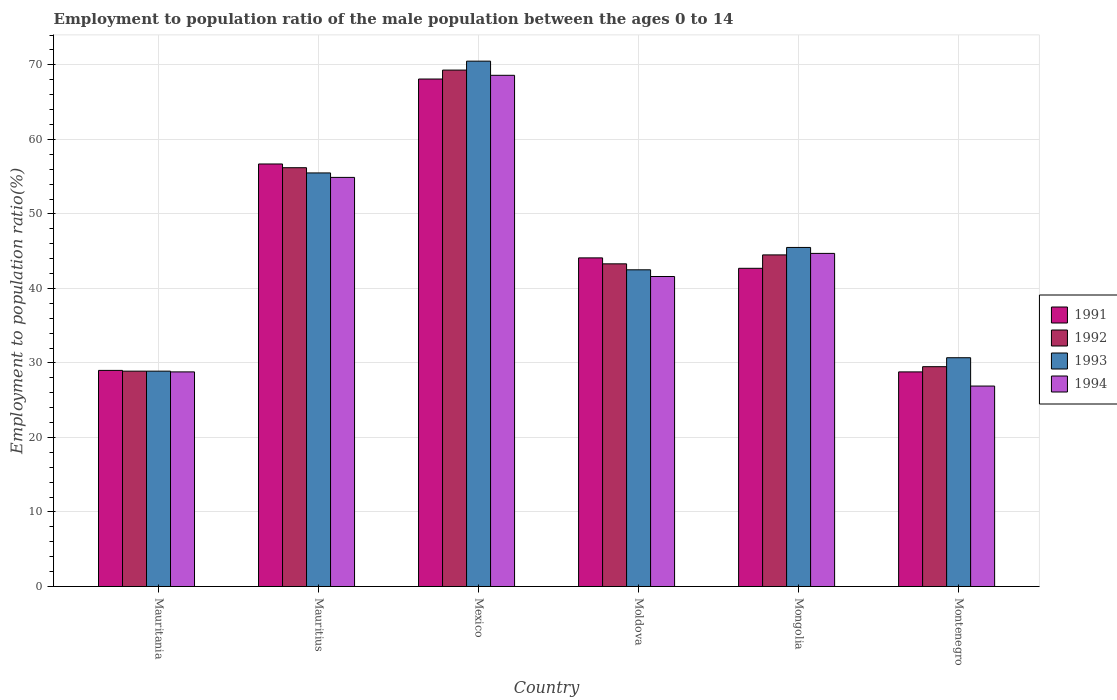Are the number of bars per tick equal to the number of legend labels?
Your answer should be very brief. Yes. Are the number of bars on each tick of the X-axis equal?
Give a very brief answer. Yes. What is the label of the 4th group of bars from the left?
Your response must be concise. Moldova. What is the employment to population ratio in 1994 in Mexico?
Make the answer very short. 68.6. Across all countries, what is the maximum employment to population ratio in 1991?
Provide a succinct answer. 68.1. Across all countries, what is the minimum employment to population ratio in 1994?
Your response must be concise. 26.9. In which country was the employment to population ratio in 1992 maximum?
Offer a very short reply. Mexico. In which country was the employment to population ratio in 1992 minimum?
Offer a terse response. Mauritania. What is the total employment to population ratio in 1992 in the graph?
Keep it short and to the point. 271.7. What is the difference between the employment to population ratio in 1993 in Moldova and the employment to population ratio in 1992 in Mauritius?
Your answer should be very brief. -13.7. What is the average employment to population ratio in 1993 per country?
Make the answer very short. 45.6. What is the difference between the employment to population ratio of/in 1993 and employment to population ratio of/in 1992 in Moldova?
Make the answer very short. -0.8. In how many countries, is the employment to population ratio in 1994 greater than 14 %?
Your answer should be compact. 6. What is the ratio of the employment to population ratio in 1993 in Mauritania to that in Moldova?
Offer a terse response. 0.68. Is the difference between the employment to population ratio in 1993 in Moldova and Montenegro greater than the difference between the employment to population ratio in 1992 in Moldova and Montenegro?
Provide a short and direct response. No. What is the difference between the highest and the second highest employment to population ratio in 1993?
Offer a terse response. -25. What is the difference between the highest and the lowest employment to population ratio in 1992?
Give a very brief answer. 40.4. In how many countries, is the employment to population ratio in 1991 greater than the average employment to population ratio in 1991 taken over all countries?
Your answer should be compact. 2. What does the 3rd bar from the right in Montenegro represents?
Make the answer very short. 1992. Is it the case that in every country, the sum of the employment to population ratio in 1991 and employment to population ratio in 1993 is greater than the employment to population ratio in 1994?
Provide a succinct answer. Yes. How many bars are there?
Your answer should be very brief. 24. Are all the bars in the graph horizontal?
Make the answer very short. No. What is the difference between two consecutive major ticks on the Y-axis?
Provide a short and direct response. 10. Are the values on the major ticks of Y-axis written in scientific E-notation?
Provide a short and direct response. No. Does the graph contain grids?
Make the answer very short. Yes. How many legend labels are there?
Your answer should be compact. 4. What is the title of the graph?
Provide a short and direct response. Employment to population ratio of the male population between the ages 0 to 14. What is the label or title of the X-axis?
Offer a terse response. Country. What is the label or title of the Y-axis?
Provide a short and direct response. Employment to population ratio(%). What is the Employment to population ratio(%) in 1992 in Mauritania?
Your response must be concise. 28.9. What is the Employment to population ratio(%) of 1993 in Mauritania?
Provide a succinct answer. 28.9. What is the Employment to population ratio(%) of 1994 in Mauritania?
Ensure brevity in your answer.  28.8. What is the Employment to population ratio(%) of 1991 in Mauritius?
Provide a succinct answer. 56.7. What is the Employment to population ratio(%) in 1992 in Mauritius?
Your answer should be compact. 56.2. What is the Employment to population ratio(%) in 1993 in Mauritius?
Your answer should be compact. 55.5. What is the Employment to population ratio(%) in 1994 in Mauritius?
Make the answer very short. 54.9. What is the Employment to population ratio(%) in 1991 in Mexico?
Your answer should be compact. 68.1. What is the Employment to population ratio(%) of 1992 in Mexico?
Give a very brief answer. 69.3. What is the Employment to population ratio(%) in 1993 in Mexico?
Your answer should be compact. 70.5. What is the Employment to population ratio(%) in 1994 in Mexico?
Your answer should be compact. 68.6. What is the Employment to population ratio(%) of 1991 in Moldova?
Make the answer very short. 44.1. What is the Employment to population ratio(%) of 1992 in Moldova?
Give a very brief answer. 43.3. What is the Employment to population ratio(%) of 1993 in Moldova?
Make the answer very short. 42.5. What is the Employment to population ratio(%) of 1994 in Moldova?
Provide a short and direct response. 41.6. What is the Employment to population ratio(%) in 1991 in Mongolia?
Offer a terse response. 42.7. What is the Employment to population ratio(%) in 1992 in Mongolia?
Ensure brevity in your answer.  44.5. What is the Employment to population ratio(%) in 1993 in Mongolia?
Give a very brief answer. 45.5. What is the Employment to population ratio(%) of 1994 in Mongolia?
Ensure brevity in your answer.  44.7. What is the Employment to population ratio(%) in 1991 in Montenegro?
Provide a succinct answer. 28.8. What is the Employment to population ratio(%) of 1992 in Montenegro?
Ensure brevity in your answer.  29.5. What is the Employment to population ratio(%) of 1993 in Montenegro?
Ensure brevity in your answer.  30.7. What is the Employment to population ratio(%) of 1994 in Montenegro?
Provide a succinct answer. 26.9. Across all countries, what is the maximum Employment to population ratio(%) in 1991?
Give a very brief answer. 68.1. Across all countries, what is the maximum Employment to population ratio(%) in 1992?
Make the answer very short. 69.3. Across all countries, what is the maximum Employment to population ratio(%) of 1993?
Keep it short and to the point. 70.5. Across all countries, what is the maximum Employment to population ratio(%) in 1994?
Offer a very short reply. 68.6. Across all countries, what is the minimum Employment to population ratio(%) in 1991?
Provide a succinct answer. 28.8. Across all countries, what is the minimum Employment to population ratio(%) in 1992?
Your answer should be compact. 28.9. Across all countries, what is the minimum Employment to population ratio(%) in 1993?
Give a very brief answer. 28.9. Across all countries, what is the minimum Employment to population ratio(%) of 1994?
Offer a terse response. 26.9. What is the total Employment to population ratio(%) of 1991 in the graph?
Make the answer very short. 269.4. What is the total Employment to population ratio(%) in 1992 in the graph?
Offer a very short reply. 271.7. What is the total Employment to population ratio(%) of 1993 in the graph?
Your answer should be compact. 273.6. What is the total Employment to population ratio(%) of 1994 in the graph?
Your answer should be very brief. 265.5. What is the difference between the Employment to population ratio(%) of 1991 in Mauritania and that in Mauritius?
Ensure brevity in your answer.  -27.7. What is the difference between the Employment to population ratio(%) in 1992 in Mauritania and that in Mauritius?
Give a very brief answer. -27.3. What is the difference between the Employment to population ratio(%) in 1993 in Mauritania and that in Mauritius?
Make the answer very short. -26.6. What is the difference between the Employment to population ratio(%) in 1994 in Mauritania and that in Mauritius?
Give a very brief answer. -26.1. What is the difference between the Employment to population ratio(%) in 1991 in Mauritania and that in Mexico?
Make the answer very short. -39.1. What is the difference between the Employment to population ratio(%) of 1992 in Mauritania and that in Mexico?
Your response must be concise. -40.4. What is the difference between the Employment to population ratio(%) in 1993 in Mauritania and that in Mexico?
Ensure brevity in your answer.  -41.6. What is the difference between the Employment to population ratio(%) of 1994 in Mauritania and that in Mexico?
Offer a terse response. -39.8. What is the difference between the Employment to population ratio(%) of 1991 in Mauritania and that in Moldova?
Offer a terse response. -15.1. What is the difference between the Employment to population ratio(%) in 1992 in Mauritania and that in Moldova?
Your answer should be compact. -14.4. What is the difference between the Employment to population ratio(%) of 1991 in Mauritania and that in Mongolia?
Ensure brevity in your answer.  -13.7. What is the difference between the Employment to population ratio(%) of 1992 in Mauritania and that in Mongolia?
Offer a very short reply. -15.6. What is the difference between the Employment to population ratio(%) in 1993 in Mauritania and that in Mongolia?
Offer a terse response. -16.6. What is the difference between the Employment to population ratio(%) in 1994 in Mauritania and that in Mongolia?
Your answer should be very brief. -15.9. What is the difference between the Employment to population ratio(%) in 1991 in Mauritania and that in Montenegro?
Keep it short and to the point. 0.2. What is the difference between the Employment to population ratio(%) in 1992 in Mauritania and that in Montenegro?
Offer a terse response. -0.6. What is the difference between the Employment to population ratio(%) in 1994 in Mauritania and that in Montenegro?
Ensure brevity in your answer.  1.9. What is the difference between the Employment to population ratio(%) in 1993 in Mauritius and that in Mexico?
Your response must be concise. -15. What is the difference between the Employment to population ratio(%) in 1994 in Mauritius and that in Mexico?
Give a very brief answer. -13.7. What is the difference between the Employment to population ratio(%) of 1991 in Mauritius and that in Moldova?
Make the answer very short. 12.6. What is the difference between the Employment to population ratio(%) of 1993 in Mauritius and that in Moldova?
Keep it short and to the point. 13. What is the difference between the Employment to population ratio(%) in 1991 in Mauritius and that in Mongolia?
Provide a succinct answer. 14. What is the difference between the Employment to population ratio(%) of 1991 in Mauritius and that in Montenegro?
Give a very brief answer. 27.9. What is the difference between the Employment to population ratio(%) in 1992 in Mauritius and that in Montenegro?
Your answer should be very brief. 26.7. What is the difference between the Employment to population ratio(%) of 1993 in Mauritius and that in Montenegro?
Ensure brevity in your answer.  24.8. What is the difference between the Employment to population ratio(%) of 1994 in Mexico and that in Moldova?
Make the answer very short. 27. What is the difference between the Employment to population ratio(%) of 1991 in Mexico and that in Mongolia?
Provide a succinct answer. 25.4. What is the difference between the Employment to population ratio(%) of 1992 in Mexico and that in Mongolia?
Ensure brevity in your answer.  24.8. What is the difference between the Employment to population ratio(%) in 1994 in Mexico and that in Mongolia?
Keep it short and to the point. 23.9. What is the difference between the Employment to population ratio(%) in 1991 in Mexico and that in Montenegro?
Offer a very short reply. 39.3. What is the difference between the Employment to population ratio(%) of 1992 in Mexico and that in Montenegro?
Your answer should be compact. 39.8. What is the difference between the Employment to population ratio(%) in 1993 in Mexico and that in Montenegro?
Offer a very short reply. 39.8. What is the difference between the Employment to population ratio(%) in 1994 in Mexico and that in Montenegro?
Offer a terse response. 41.7. What is the difference between the Employment to population ratio(%) of 1992 in Moldova and that in Mongolia?
Offer a terse response. -1.2. What is the difference between the Employment to population ratio(%) in 1991 in Moldova and that in Montenegro?
Keep it short and to the point. 15.3. What is the difference between the Employment to population ratio(%) of 1991 in Mongolia and that in Montenegro?
Provide a short and direct response. 13.9. What is the difference between the Employment to population ratio(%) of 1992 in Mongolia and that in Montenegro?
Your answer should be very brief. 15. What is the difference between the Employment to population ratio(%) of 1994 in Mongolia and that in Montenegro?
Provide a short and direct response. 17.8. What is the difference between the Employment to population ratio(%) of 1991 in Mauritania and the Employment to population ratio(%) of 1992 in Mauritius?
Offer a very short reply. -27.2. What is the difference between the Employment to population ratio(%) in 1991 in Mauritania and the Employment to population ratio(%) in 1993 in Mauritius?
Your response must be concise. -26.5. What is the difference between the Employment to population ratio(%) of 1991 in Mauritania and the Employment to population ratio(%) of 1994 in Mauritius?
Make the answer very short. -25.9. What is the difference between the Employment to population ratio(%) in 1992 in Mauritania and the Employment to population ratio(%) in 1993 in Mauritius?
Give a very brief answer. -26.6. What is the difference between the Employment to population ratio(%) in 1992 in Mauritania and the Employment to population ratio(%) in 1994 in Mauritius?
Make the answer very short. -26. What is the difference between the Employment to population ratio(%) in 1993 in Mauritania and the Employment to population ratio(%) in 1994 in Mauritius?
Keep it short and to the point. -26. What is the difference between the Employment to population ratio(%) in 1991 in Mauritania and the Employment to population ratio(%) in 1992 in Mexico?
Keep it short and to the point. -40.3. What is the difference between the Employment to population ratio(%) in 1991 in Mauritania and the Employment to population ratio(%) in 1993 in Mexico?
Give a very brief answer. -41.5. What is the difference between the Employment to population ratio(%) in 1991 in Mauritania and the Employment to population ratio(%) in 1994 in Mexico?
Make the answer very short. -39.6. What is the difference between the Employment to population ratio(%) in 1992 in Mauritania and the Employment to population ratio(%) in 1993 in Mexico?
Keep it short and to the point. -41.6. What is the difference between the Employment to population ratio(%) of 1992 in Mauritania and the Employment to population ratio(%) of 1994 in Mexico?
Your answer should be very brief. -39.7. What is the difference between the Employment to population ratio(%) of 1993 in Mauritania and the Employment to population ratio(%) of 1994 in Mexico?
Make the answer very short. -39.7. What is the difference between the Employment to population ratio(%) in 1991 in Mauritania and the Employment to population ratio(%) in 1992 in Moldova?
Your answer should be very brief. -14.3. What is the difference between the Employment to population ratio(%) of 1991 in Mauritania and the Employment to population ratio(%) of 1993 in Moldova?
Offer a terse response. -13.5. What is the difference between the Employment to population ratio(%) in 1991 in Mauritania and the Employment to population ratio(%) in 1994 in Moldova?
Provide a succinct answer. -12.6. What is the difference between the Employment to population ratio(%) in 1992 in Mauritania and the Employment to population ratio(%) in 1993 in Moldova?
Keep it short and to the point. -13.6. What is the difference between the Employment to population ratio(%) of 1993 in Mauritania and the Employment to population ratio(%) of 1994 in Moldova?
Keep it short and to the point. -12.7. What is the difference between the Employment to population ratio(%) of 1991 in Mauritania and the Employment to population ratio(%) of 1992 in Mongolia?
Keep it short and to the point. -15.5. What is the difference between the Employment to population ratio(%) of 1991 in Mauritania and the Employment to population ratio(%) of 1993 in Mongolia?
Keep it short and to the point. -16.5. What is the difference between the Employment to population ratio(%) of 1991 in Mauritania and the Employment to population ratio(%) of 1994 in Mongolia?
Your answer should be compact. -15.7. What is the difference between the Employment to population ratio(%) of 1992 in Mauritania and the Employment to population ratio(%) of 1993 in Mongolia?
Offer a very short reply. -16.6. What is the difference between the Employment to population ratio(%) of 1992 in Mauritania and the Employment to population ratio(%) of 1994 in Mongolia?
Your response must be concise. -15.8. What is the difference between the Employment to population ratio(%) in 1993 in Mauritania and the Employment to population ratio(%) in 1994 in Mongolia?
Provide a succinct answer. -15.8. What is the difference between the Employment to population ratio(%) in 1992 in Mauritania and the Employment to population ratio(%) in 1993 in Montenegro?
Give a very brief answer. -1.8. What is the difference between the Employment to population ratio(%) in 1992 in Mauritius and the Employment to population ratio(%) in 1993 in Mexico?
Offer a very short reply. -14.3. What is the difference between the Employment to population ratio(%) of 1992 in Mauritius and the Employment to population ratio(%) of 1994 in Mexico?
Ensure brevity in your answer.  -12.4. What is the difference between the Employment to population ratio(%) in 1991 in Mauritius and the Employment to population ratio(%) in 1994 in Moldova?
Provide a succinct answer. 15.1. What is the difference between the Employment to population ratio(%) of 1992 in Mauritius and the Employment to population ratio(%) of 1993 in Moldova?
Offer a terse response. 13.7. What is the difference between the Employment to population ratio(%) of 1992 in Mauritius and the Employment to population ratio(%) of 1994 in Moldova?
Keep it short and to the point. 14.6. What is the difference between the Employment to population ratio(%) of 1991 in Mauritius and the Employment to population ratio(%) of 1994 in Mongolia?
Provide a short and direct response. 12. What is the difference between the Employment to population ratio(%) of 1993 in Mauritius and the Employment to population ratio(%) of 1994 in Mongolia?
Make the answer very short. 10.8. What is the difference between the Employment to population ratio(%) in 1991 in Mauritius and the Employment to population ratio(%) in 1992 in Montenegro?
Offer a terse response. 27.2. What is the difference between the Employment to population ratio(%) in 1991 in Mauritius and the Employment to population ratio(%) in 1993 in Montenegro?
Keep it short and to the point. 26. What is the difference between the Employment to population ratio(%) in 1991 in Mauritius and the Employment to population ratio(%) in 1994 in Montenegro?
Give a very brief answer. 29.8. What is the difference between the Employment to population ratio(%) in 1992 in Mauritius and the Employment to population ratio(%) in 1993 in Montenegro?
Provide a succinct answer. 25.5. What is the difference between the Employment to population ratio(%) in 1992 in Mauritius and the Employment to population ratio(%) in 1994 in Montenegro?
Offer a terse response. 29.3. What is the difference between the Employment to population ratio(%) of 1993 in Mauritius and the Employment to population ratio(%) of 1994 in Montenegro?
Your answer should be very brief. 28.6. What is the difference between the Employment to population ratio(%) in 1991 in Mexico and the Employment to population ratio(%) in 1992 in Moldova?
Offer a very short reply. 24.8. What is the difference between the Employment to population ratio(%) in 1991 in Mexico and the Employment to population ratio(%) in 1993 in Moldova?
Your answer should be very brief. 25.6. What is the difference between the Employment to population ratio(%) of 1992 in Mexico and the Employment to population ratio(%) of 1993 in Moldova?
Give a very brief answer. 26.8. What is the difference between the Employment to population ratio(%) in 1992 in Mexico and the Employment to population ratio(%) in 1994 in Moldova?
Your response must be concise. 27.7. What is the difference between the Employment to population ratio(%) in 1993 in Mexico and the Employment to population ratio(%) in 1994 in Moldova?
Your response must be concise. 28.9. What is the difference between the Employment to population ratio(%) of 1991 in Mexico and the Employment to population ratio(%) of 1992 in Mongolia?
Offer a terse response. 23.6. What is the difference between the Employment to population ratio(%) of 1991 in Mexico and the Employment to population ratio(%) of 1993 in Mongolia?
Your answer should be very brief. 22.6. What is the difference between the Employment to population ratio(%) of 1991 in Mexico and the Employment to population ratio(%) of 1994 in Mongolia?
Make the answer very short. 23.4. What is the difference between the Employment to population ratio(%) of 1992 in Mexico and the Employment to population ratio(%) of 1993 in Mongolia?
Offer a terse response. 23.8. What is the difference between the Employment to population ratio(%) in 1992 in Mexico and the Employment to population ratio(%) in 1994 in Mongolia?
Provide a short and direct response. 24.6. What is the difference between the Employment to population ratio(%) in 1993 in Mexico and the Employment to population ratio(%) in 1994 in Mongolia?
Give a very brief answer. 25.8. What is the difference between the Employment to population ratio(%) in 1991 in Mexico and the Employment to population ratio(%) in 1992 in Montenegro?
Offer a terse response. 38.6. What is the difference between the Employment to population ratio(%) in 1991 in Mexico and the Employment to population ratio(%) in 1993 in Montenegro?
Your answer should be very brief. 37.4. What is the difference between the Employment to population ratio(%) of 1991 in Mexico and the Employment to population ratio(%) of 1994 in Montenegro?
Your response must be concise. 41.2. What is the difference between the Employment to population ratio(%) in 1992 in Mexico and the Employment to population ratio(%) in 1993 in Montenegro?
Your answer should be compact. 38.6. What is the difference between the Employment to population ratio(%) of 1992 in Mexico and the Employment to population ratio(%) of 1994 in Montenegro?
Give a very brief answer. 42.4. What is the difference between the Employment to population ratio(%) of 1993 in Mexico and the Employment to population ratio(%) of 1994 in Montenegro?
Give a very brief answer. 43.6. What is the difference between the Employment to population ratio(%) in 1991 in Moldova and the Employment to population ratio(%) in 1992 in Mongolia?
Your answer should be compact. -0.4. What is the difference between the Employment to population ratio(%) in 1993 in Moldova and the Employment to population ratio(%) in 1994 in Mongolia?
Provide a short and direct response. -2.2. What is the difference between the Employment to population ratio(%) in 1991 in Moldova and the Employment to population ratio(%) in 1992 in Montenegro?
Provide a short and direct response. 14.6. What is the difference between the Employment to population ratio(%) in 1991 in Moldova and the Employment to population ratio(%) in 1993 in Montenegro?
Make the answer very short. 13.4. What is the difference between the Employment to population ratio(%) of 1991 in Moldova and the Employment to population ratio(%) of 1994 in Montenegro?
Ensure brevity in your answer.  17.2. What is the difference between the Employment to population ratio(%) of 1991 in Mongolia and the Employment to population ratio(%) of 1992 in Montenegro?
Provide a succinct answer. 13.2. What is the difference between the Employment to population ratio(%) in 1991 in Mongolia and the Employment to population ratio(%) in 1994 in Montenegro?
Ensure brevity in your answer.  15.8. What is the difference between the Employment to population ratio(%) in 1992 in Mongolia and the Employment to population ratio(%) in 1993 in Montenegro?
Your response must be concise. 13.8. What is the average Employment to population ratio(%) in 1991 per country?
Give a very brief answer. 44.9. What is the average Employment to population ratio(%) of 1992 per country?
Your answer should be compact. 45.28. What is the average Employment to population ratio(%) in 1993 per country?
Make the answer very short. 45.6. What is the average Employment to population ratio(%) of 1994 per country?
Your answer should be compact. 44.25. What is the difference between the Employment to population ratio(%) of 1991 and Employment to population ratio(%) of 1992 in Mauritania?
Your response must be concise. 0.1. What is the difference between the Employment to population ratio(%) in 1991 and Employment to population ratio(%) in 1993 in Mauritania?
Your response must be concise. 0.1. What is the difference between the Employment to population ratio(%) in 1992 and Employment to population ratio(%) in 1993 in Mauritania?
Your answer should be very brief. 0. What is the difference between the Employment to population ratio(%) in 1993 and Employment to population ratio(%) in 1994 in Mauritania?
Your response must be concise. 0.1. What is the difference between the Employment to population ratio(%) of 1991 and Employment to population ratio(%) of 1992 in Mauritius?
Your answer should be compact. 0.5. What is the difference between the Employment to population ratio(%) in 1992 and Employment to population ratio(%) in 1993 in Mauritius?
Your response must be concise. 0.7. What is the difference between the Employment to population ratio(%) of 1993 and Employment to population ratio(%) of 1994 in Mauritius?
Your answer should be compact. 0.6. What is the difference between the Employment to population ratio(%) in 1991 and Employment to population ratio(%) in 1992 in Mexico?
Your answer should be very brief. -1.2. What is the difference between the Employment to population ratio(%) in 1991 and Employment to population ratio(%) in 1993 in Mexico?
Ensure brevity in your answer.  -2.4. What is the difference between the Employment to population ratio(%) in 1992 and Employment to population ratio(%) in 1993 in Mexico?
Your answer should be compact. -1.2. What is the difference between the Employment to population ratio(%) of 1991 and Employment to population ratio(%) of 1992 in Moldova?
Keep it short and to the point. 0.8. What is the difference between the Employment to population ratio(%) in 1991 and Employment to population ratio(%) in 1993 in Moldova?
Give a very brief answer. 1.6. What is the difference between the Employment to population ratio(%) of 1993 and Employment to population ratio(%) of 1994 in Moldova?
Give a very brief answer. 0.9. What is the difference between the Employment to population ratio(%) of 1991 and Employment to population ratio(%) of 1992 in Mongolia?
Your answer should be compact. -1.8. What is the difference between the Employment to population ratio(%) in 1992 and Employment to population ratio(%) in 1993 in Mongolia?
Keep it short and to the point. -1. What is the difference between the Employment to population ratio(%) in 1992 and Employment to population ratio(%) in 1994 in Mongolia?
Make the answer very short. -0.2. What is the difference between the Employment to population ratio(%) of 1991 and Employment to population ratio(%) of 1992 in Montenegro?
Offer a very short reply. -0.7. What is the difference between the Employment to population ratio(%) of 1991 and Employment to population ratio(%) of 1993 in Montenegro?
Provide a short and direct response. -1.9. What is the difference between the Employment to population ratio(%) of 1992 and Employment to population ratio(%) of 1993 in Montenegro?
Give a very brief answer. -1.2. What is the difference between the Employment to population ratio(%) in 1992 and Employment to population ratio(%) in 1994 in Montenegro?
Offer a very short reply. 2.6. What is the ratio of the Employment to population ratio(%) in 1991 in Mauritania to that in Mauritius?
Your answer should be compact. 0.51. What is the ratio of the Employment to population ratio(%) of 1992 in Mauritania to that in Mauritius?
Provide a short and direct response. 0.51. What is the ratio of the Employment to population ratio(%) in 1993 in Mauritania to that in Mauritius?
Offer a very short reply. 0.52. What is the ratio of the Employment to population ratio(%) of 1994 in Mauritania to that in Mauritius?
Ensure brevity in your answer.  0.52. What is the ratio of the Employment to population ratio(%) in 1991 in Mauritania to that in Mexico?
Ensure brevity in your answer.  0.43. What is the ratio of the Employment to population ratio(%) in 1992 in Mauritania to that in Mexico?
Your answer should be compact. 0.42. What is the ratio of the Employment to population ratio(%) in 1993 in Mauritania to that in Mexico?
Provide a short and direct response. 0.41. What is the ratio of the Employment to population ratio(%) of 1994 in Mauritania to that in Mexico?
Offer a very short reply. 0.42. What is the ratio of the Employment to population ratio(%) in 1991 in Mauritania to that in Moldova?
Provide a short and direct response. 0.66. What is the ratio of the Employment to population ratio(%) in 1992 in Mauritania to that in Moldova?
Give a very brief answer. 0.67. What is the ratio of the Employment to population ratio(%) in 1993 in Mauritania to that in Moldova?
Provide a succinct answer. 0.68. What is the ratio of the Employment to population ratio(%) in 1994 in Mauritania to that in Moldova?
Your answer should be compact. 0.69. What is the ratio of the Employment to population ratio(%) in 1991 in Mauritania to that in Mongolia?
Your answer should be compact. 0.68. What is the ratio of the Employment to population ratio(%) of 1992 in Mauritania to that in Mongolia?
Offer a very short reply. 0.65. What is the ratio of the Employment to population ratio(%) of 1993 in Mauritania to that in Mongolia?
Ensure brevity in your answer.  0.64. What is the ratio of the Employment to population ratio(%) in 1994 in Mauritania to that in Mongolia?
Provide a short and direct response. 0.64. What is the ratio of the Employment to population ratio(%) in 1992 in Mauritania to that in Montenegro?
Offer a very short reply. 0.98. What is the ratio of the Employment to population ratio(%) in 1993 in Mauritania to that in Montenegro?
Offer a terse response. 0.94. What is the ratio of the Employment to population ratio(%) in 1994 in Mauritania to that in Montenegro?
Provide a short and direct response. 1.07. What is the ratio of the Employment to population ratio(%) in 1991 in Mauritius to that in Mexico?
Offer a terse response. 0.83. What is the ratio of the Employment to population ratio(%) of 1992 in Mauritius to that in Mexico?
Offer a very short reply. 0.81. What is the ratio of the Employment to population ratio(%) of 1993 in Mauritius to that in Mexico?
Offer a terse response. 0.79. What is the ratio of the Employment to population ratio(%) in 1994 in Mauritius to that in Mexico?
Your answer should be very brief. 0.8. What is the ratio of the Employment to population ratio(%) in 1992 in Mauritius to that in Moldova?
Make the answer very short. 1.3. What is the ratio of the Employment to population ratio(%) in 1993 in Mauritius to that in Moldova?
Keep it short and to the point. 1.31. What is the ratio of the Employment to population ratio(%) of 1994 in Mauritius to that in Moldova?
Your answer should be compact. 1.32. What is the ratio of the Employment to population ratio(%) of 1991 in Mauritius to that in Mongolia?
Ensure brevity in your answer.  1.33. What is the ratio of the Employment to population ratio(%) in 1992 in Mauritius to that in Mongolia?
Offer a very short reply. 1.26. What is the ratio of the Employment to population ratio(%) in 1993 in Mauritius to that in Mongolia?
Make the answer very short. 1.22. What is the ratio of the Employment to population ratio(%) in 1994 in Mauritius to that in Mongolia?
Give a very brief answer. 1.23. What is the ratio of the Employment to population ratio(%) of 1991 in Mauritius to that in Montenegro?
Give a very brief answer. 1.97. What is the ratio of the Employment to population ratio(%) of 1992 in Mauritius to that in Montenegro?
Give a very brief answer. 1.91. What is the ratio of the Employment to population ratio(%) in 1993 in Mauritius to that in Montenegro?
Offer a terse response. 1.81. What is the ratio of the Employment to population ratio(%) of 1994 in Mauritius to that in Montenegro?
Offer a terse response. 2.04. What is the ratio of the Employment to population ratio(%) in 1991 in Mexico to that in Moldova?
Provide a succinct answer. 1.54. What is the ratio of the Employment to population ratio(%) in 1992 in Mexico to that in Moldova?
Your answer should be compact. 1.6. What is the ratio of the Employment to population ratio(%) in 1993 in Mexico to that in Moldova?
Your answer should be compact. 1.66. What is the ratio of the Employment to population ratio(%) of 1994 in Mexico to that in Moldova?
Offer a terse response. 1.65. What is the ratio of the Employment to population ratio(%) in 1991 in Mexico to that in Mongolia?
Keep it short and to the point. 1.59. What is the ratio of the Employment to population ratio(%) in 1992 in Mexico to that in Mongolia?
Offer a terse response. 1.56. What is the ratio of the Employment to population ratio(%) in 1993 in Mexico to that in Mongolia?
Offer a terse response. 1.55. What is the ratio of the Employment to population ratio(%) in 1994 in Mexico to that in Mongolia?
Provide a succinct answer. 1.53. What is the ratio of the Employment to population ratio(%) of 1991 in Mexico to that in Montenegro?
Your response must be concise. 2.36. What is the ratio of the Employment to population ratio(%) in 1992 in Mexico to that in Montenegro?
Offer a terse response. 2.35. What is the ratio of the Employment to population ratio(%) of 1993 in Mexico to that in Montenegro?
Your answer should be very brief. 2.3. What is the ratio of the Employment to population ratio(%) of 1994 in Mexico to that in Montenegro?
Provide a succinct answer. 2.55. What is the ratio of the Employment to population ratio(%) of 1991 in Moldova to that in Mongolia?
Your answer should be very brief. 1.03. What is the ratio of the Employment to population ratio(%) in 1992 in Moldova to that in Mongolia?
Provide a short and direct response. 0.97. What is the ratio of the Employment to population ratio(%) of 1993 in Moldova to that in Mongolia?
Provide a succinct answer. 0.93. What is the ratio of the Employment to population ratio(%) in 1994 in Moldova to that in Mongolia?
Keep it short and to the point. 0.93. What is the ratio of the Employment to population ratio(%) of 1991 in Moldova to that in Montenegro?
Provide a short and direct response. 1.53. What is the ratio of the Employment to population ratio(%) in 1992 in Moldova to that in Montenegro?
Ensure brevity in your answer.  1.47. What is the ratio of the Employment to population ratio(%) of 1993 in Moldova to that in Montenegro?
Your response must be concise. 1.38. What is the ratio of the Employment to population ratio(%) in 1994 in Moldova to that in Montenegro?
Ensure brevity in your answer.  1.55. What is the ratio of the Employment to population ratio(%) of 1991 in Mongolia to that in Montenegro?
Your response must be concise. 1.48. What is the ratio of the Employment to population ratio(%) in 1992 in Mongolia to that in Montenegro?
Your answer should be very brief. 1.51. What is the ratio of the Employment to population ratio(%) in 1993 in Mongolia to that in Montenegro?
Provide a succinct answer. 1.48. What is the ratio of the Employment to population ratio(%) of 1994 in Mongolia to that in Montenegro?
Your answer should be very brief. 1.66. What is the difference between the highest and the lowest Employment to population ratio(%) of 1991?
Offer a terse response. 39.3. What is the difference between the highest and the lowest Employment to population ratio(%) of 1992?
Ensure brevity in your answer.  40.4. What is the difference between the highest and the lowest Employment to population ratio(%) in 1993?
Make the answer very short. 41.6. What is the difference between the highest and the lowest Employment to population ratio(%) in 1994?
Your answer should be very brief. 41.7. 